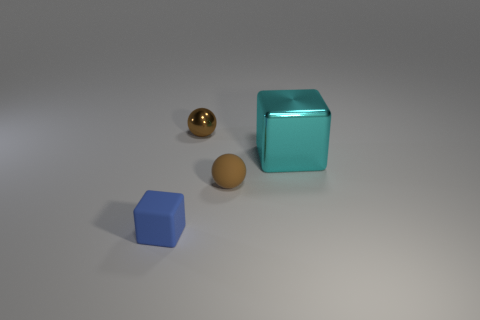What is the material of the small thing that is to the left of the brown rubber object and behind the blue thing? metal 